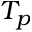Convert formula to latex. <formula><loc_0><loc_0><loc_500><loc_500>T _ { p }</formula> 